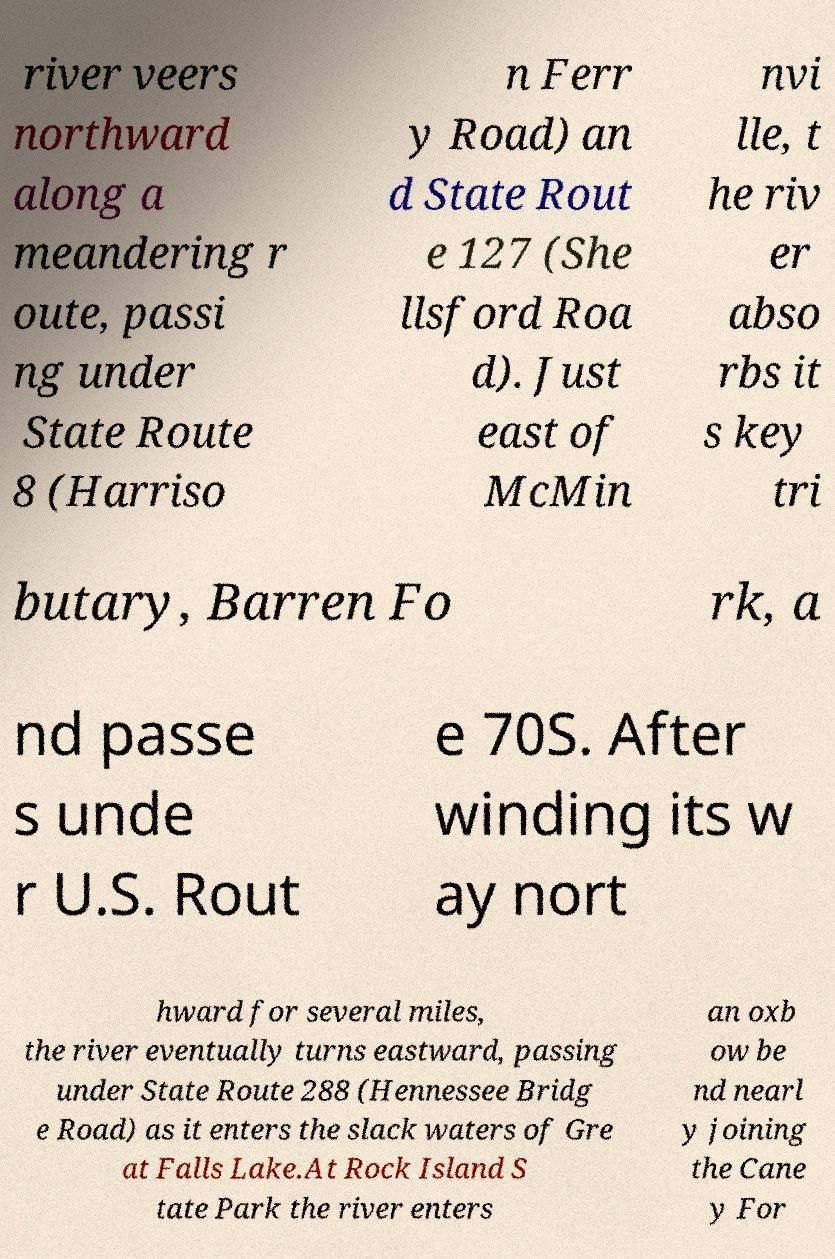For documentation purposes, I need the text within this image transcribed. Could you provide that? river veers northward along a meandering r oute, passi ng under State Route 8 (Harriso n Ferr y Road) an d State Rout e 127 (She llsford Roa d). Just east of McMin nvi lle, t he riv er abso rbs it s key tri butary, Barren Fo rk, a nd passe s unde r U.S. Rout e 70S. After winding its w ay nort hward for several miles, the river eventually turns eastward, passing under State Route 288 (Hennessee Bridg e Road) as it enters the slack waters of Gre at Falls Lake.At Rock Island S tate Park the river enters an oxb ow be nd nearl y joining the Cane y For 